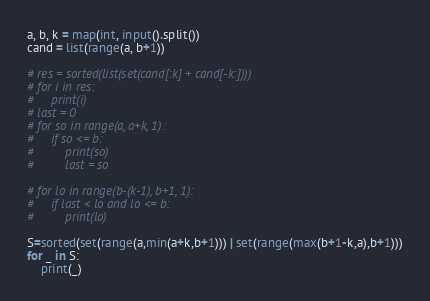<code> <loc_0><loc_0><loc_500><loc_500><_Python_>a, b, k = map(int, input().split())
cand = list(range(a, b+1))

# res = sorted(list(set(cand[:k] + cand[-k:])))
# for i in res:
#     print(i)
# last = 0
# for so in range(a, a+k, 1):
#     if so <= b:
#         print(so)
#         last = so

# for lo in range(b-(k-1), b+1, 1):
#     if last < lo and lo <= b:
#         print(lo)

S=sorted(set(range(a,min(a+k,b+1))) | set(range(max(b+1-k,a),b+1)))
for _ in S:
    print(_)</code> 